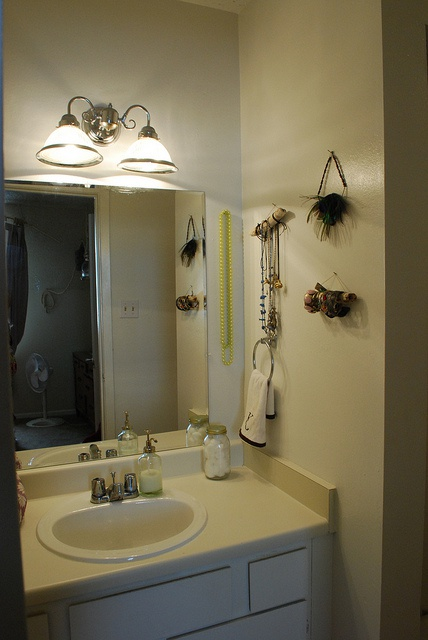Describe the objects in this image and their specific colors. I can see sink in blue, olive, tan, and gray tones, bottle in blue, gray, and olive tones, bottle in blue, olive, and darkgreen tones, and bottle in blue, olive, and gray tones in this image. 